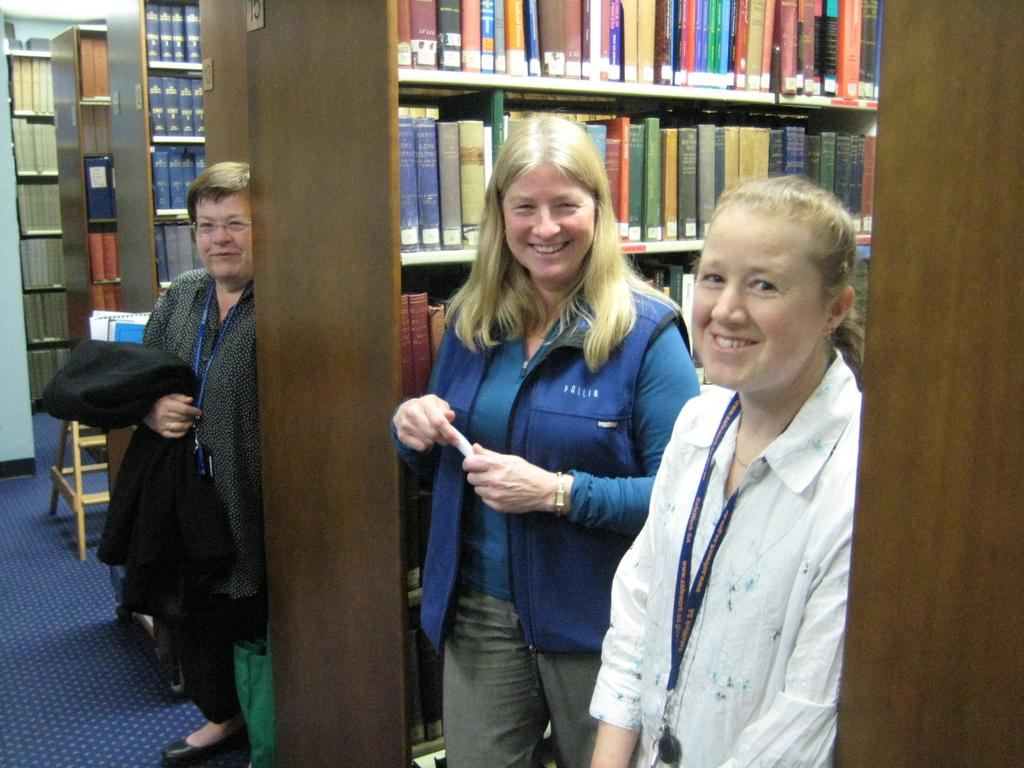How many people are in the image? There are three persons in the image. What are the persons doing in the image? The persons are standing. What can be seen on the racks in the image? There are books on the racks. What is one person holding in the image? One person is holding a cloth. What type of nose can be seen on the books in the image? There are no noses present on the books in the image; they are simply books on the racks. How much sugar is being used by the person holding the cloth in the image? There is no sugar or indication of sugar use in the image; one person is simply holding a cloth. 